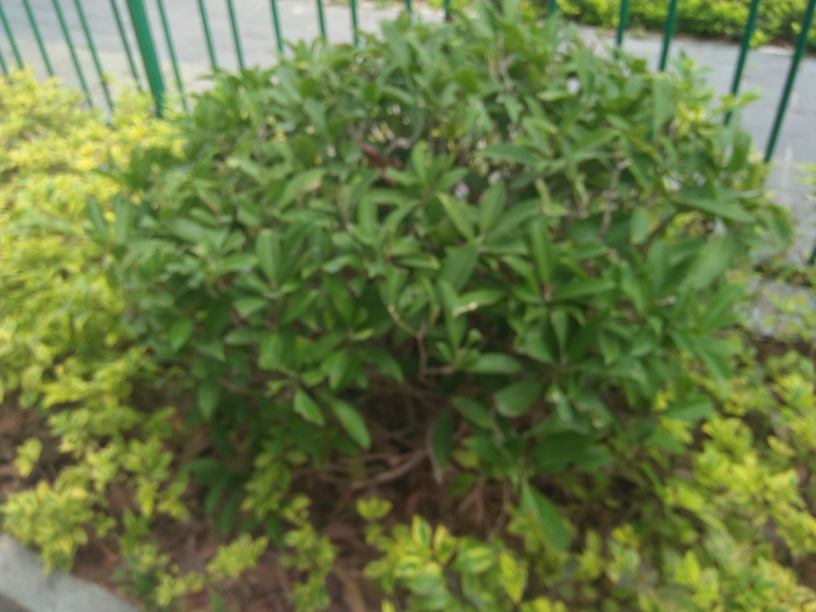How could the photograph be improved? To improve this photograph, one could use a steadier hand or a tripod to avoid camera shake and carefully adjust the focus to ensure the main subject is sharp. Additionally, taking the photo with sufficient lighting or using editing software to correct the exposure could enhance the visual clarity. 